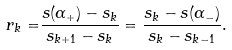Convert formula to latex. <formula><loc_0><loc_0><loc_500><loc_500>r _ { k } = & \frac { s ( \alpha _ { + } ) - s _ { k } } { s _ { k + 1 } - s _ { k } } = \frac { s _ { k } - s ( \alpha _ { - } ) } { s _ { k } - s _ { k - 1 } } .</formula> 